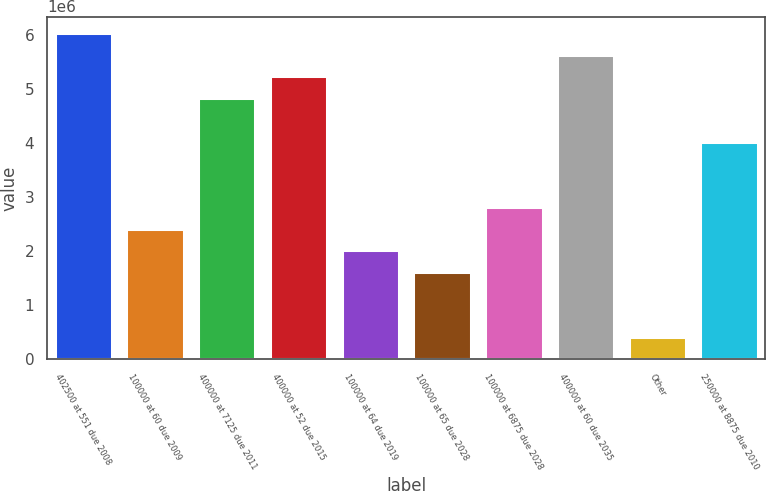Convert chart. <chart><loc_0><loc_0><loc_500><loc_500><bar_chart><fcel>402500 at 551 due 2008<fcel>100000 at 60 due 2009<fcel>400000 at 7125 due 2011<fcel>400000 at 52 due 2015<fcel>100000 at 64 due 2019<fcel>100000 at 65 due 2028<fcel>100000 at 6875 due 2028<fcel>400000 at 60 due 2035<fcel>Other<fcel>250000 at 8875 due 2010<nl><fcel>6.04478e+06<fcel>2.41971e+06<fcel>4.83643e+06<fcel>5.23921e+06<fcel>2.01693e+06<fcel>1.61414e+06<fcel>2.8225e+06<fcel>5.642e+06<fcel>405783<fcel>4.03086e+06<nl></chart> 